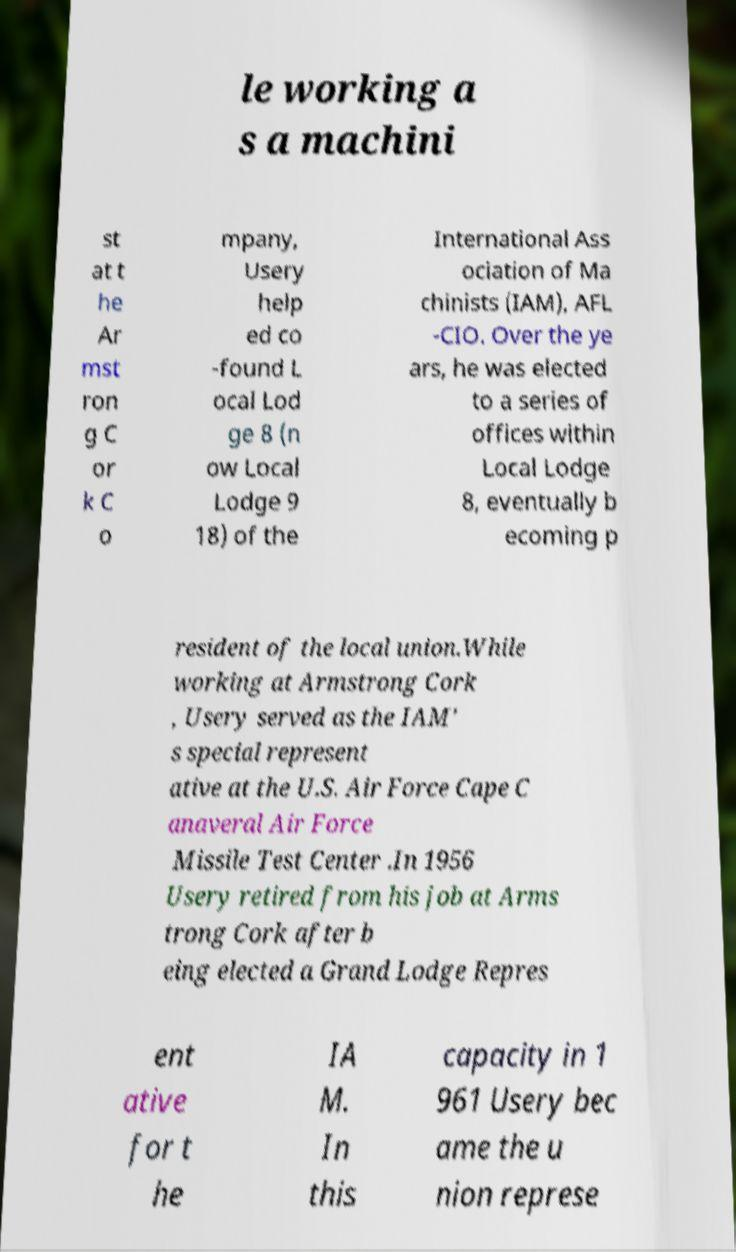For documentation purposes, I need the text within this image transcribed. Could you provide that? le working a s a machini st at t he Ar mst ron g C or k C o mpany, Usery help ed co -found L ocal Lod ge 8 (n ow Local Lodge 9 18) of the International Ass ociation of Ma chinists (IAM), AFL -CIO. Over the ye ars, he was elected to a series of offices within Local Lodge 8, eventually b ecoming p resident of the local union.While working at Armstrong Cork , Usery served as the IAM' s special represent ative at the U.S. Air Force Cape C anaveral Air Force Missile Test Center .In 1956 Usery retired from his job at Arms trong Cork after b eing elected a Grand Lodge Repres ent ative for t he IA M. In this capacity in 1 961 Usery bec ame the u nion represe 